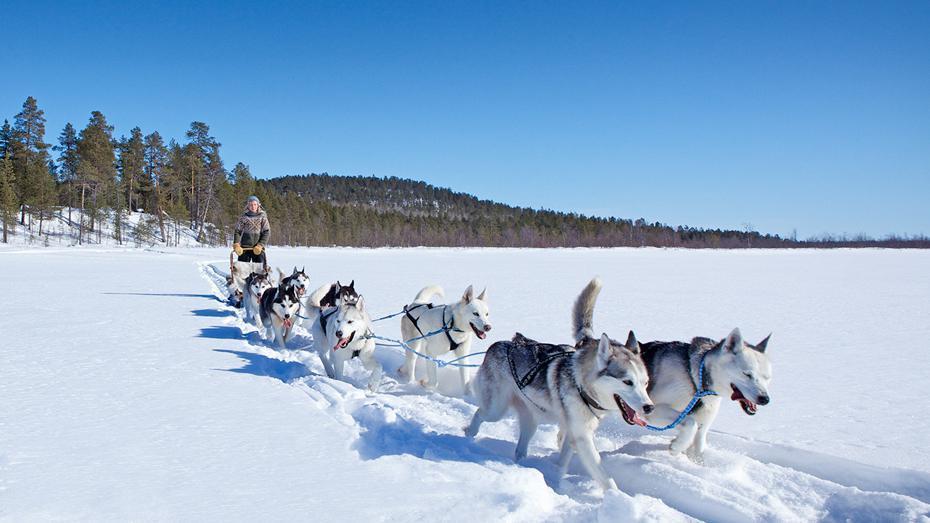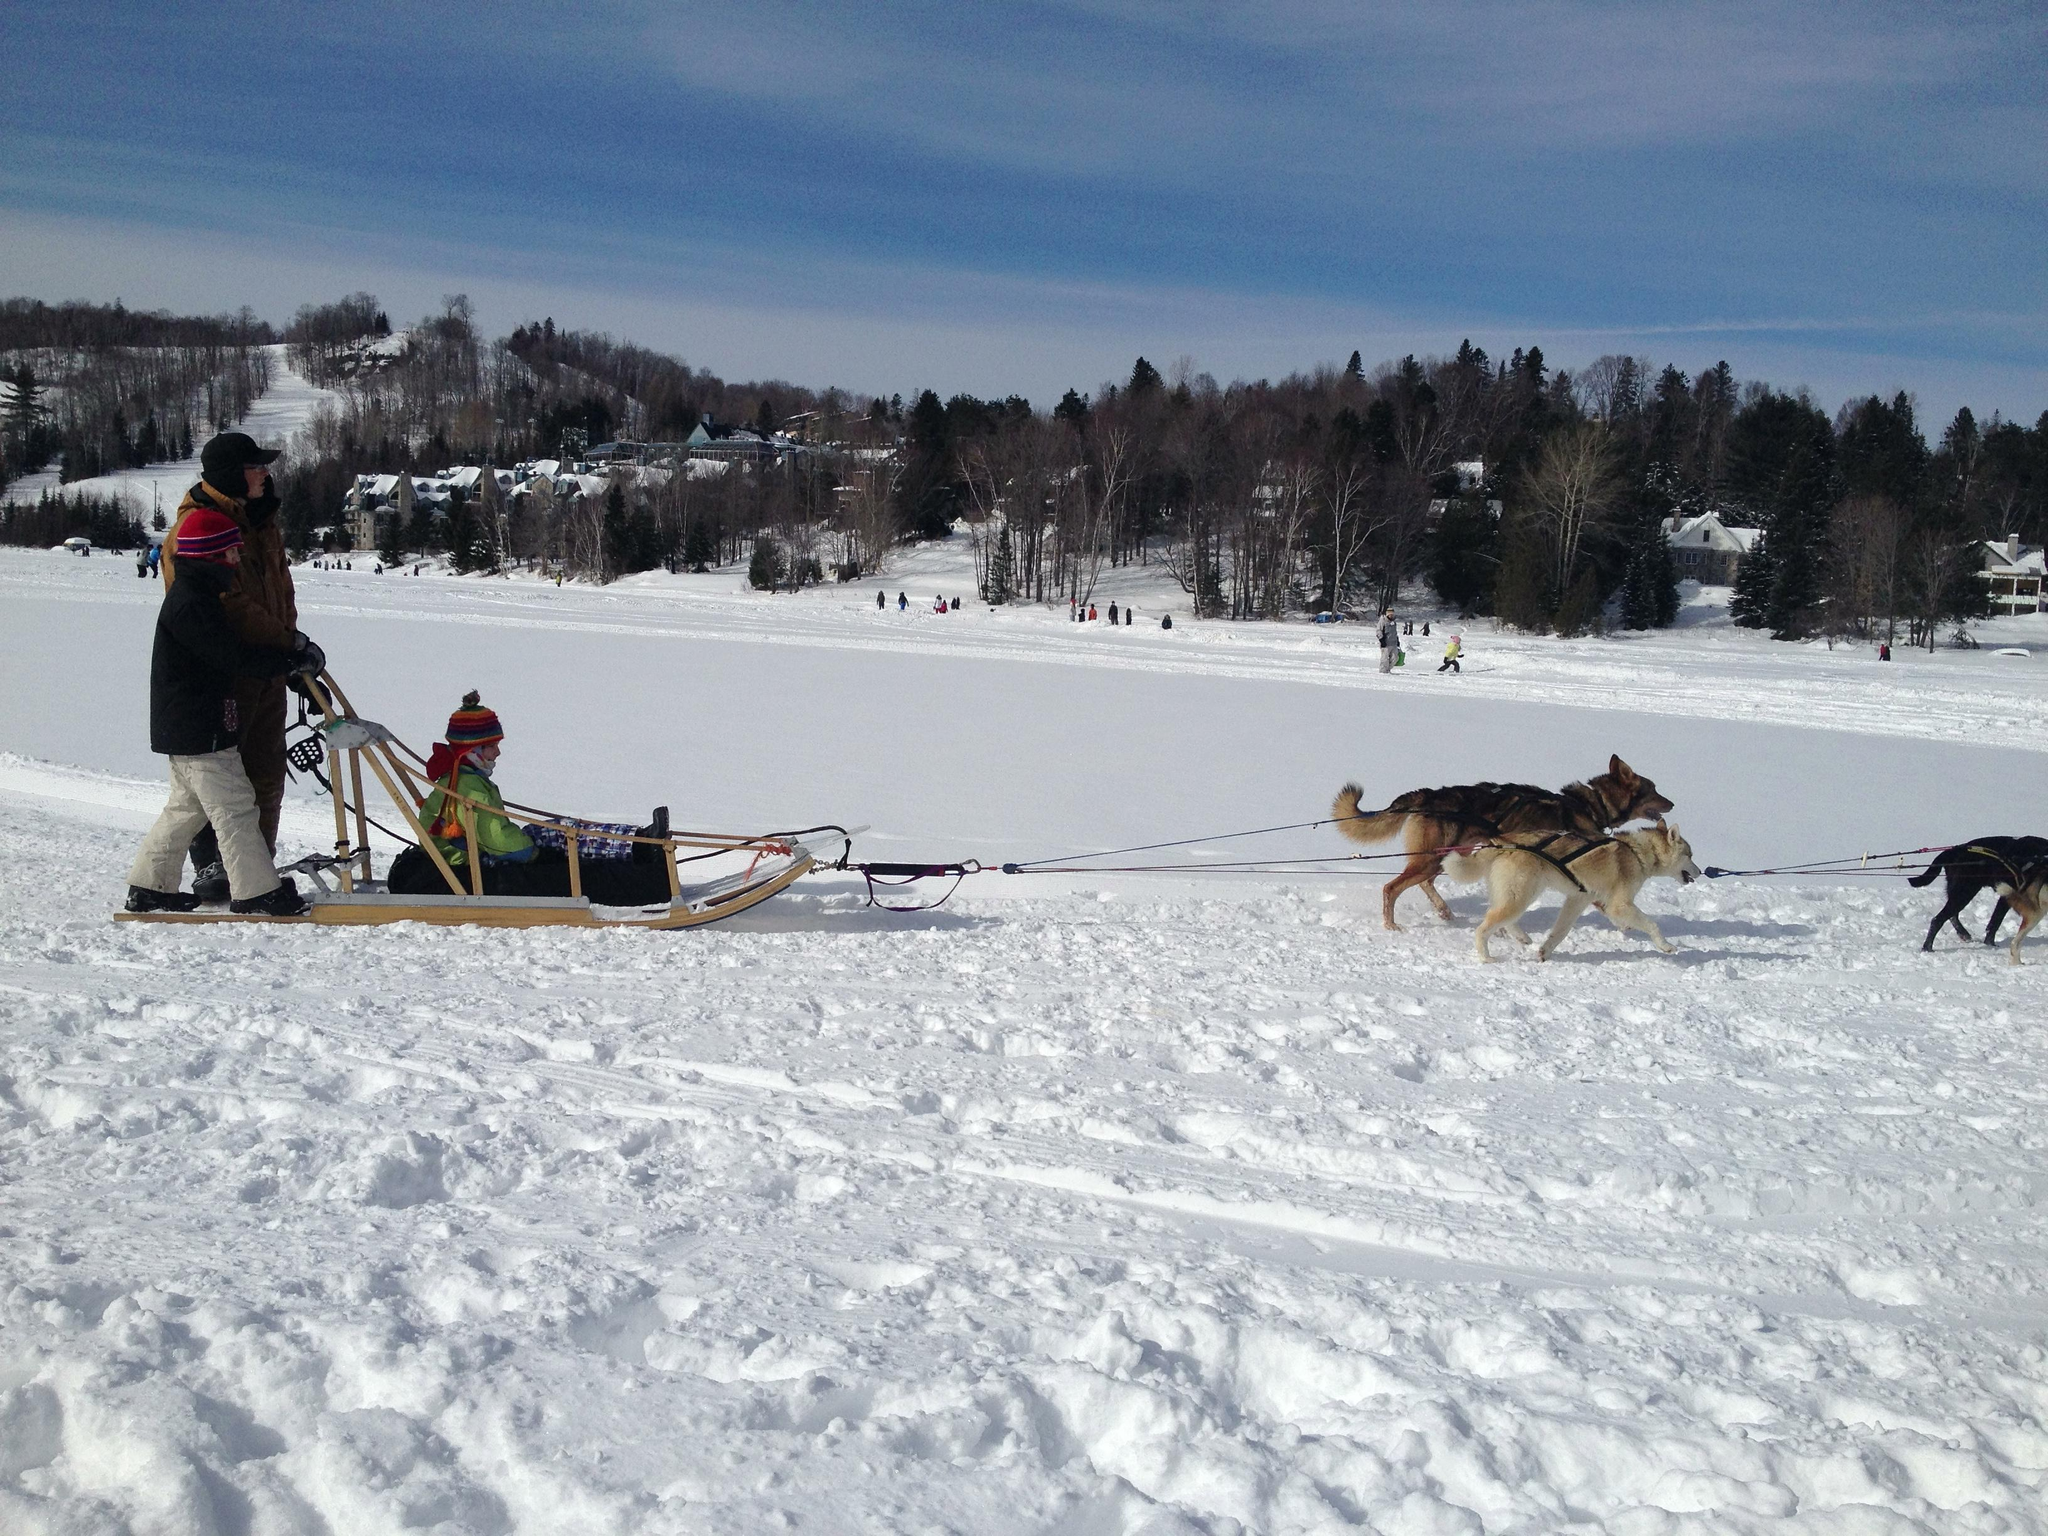The first image is the image on the left, the second image is the image on the right. For the images shown, is this caption "The dog team in the left image is heading right, and the dog team in the right image is heading left." true? Answer yes or no. No. The first image is the image on the left, the second image is the image on the right. For the images shown, is this caption "In one of the images, a dogsled is headed towards the left." true? Answer yes or no. No. 